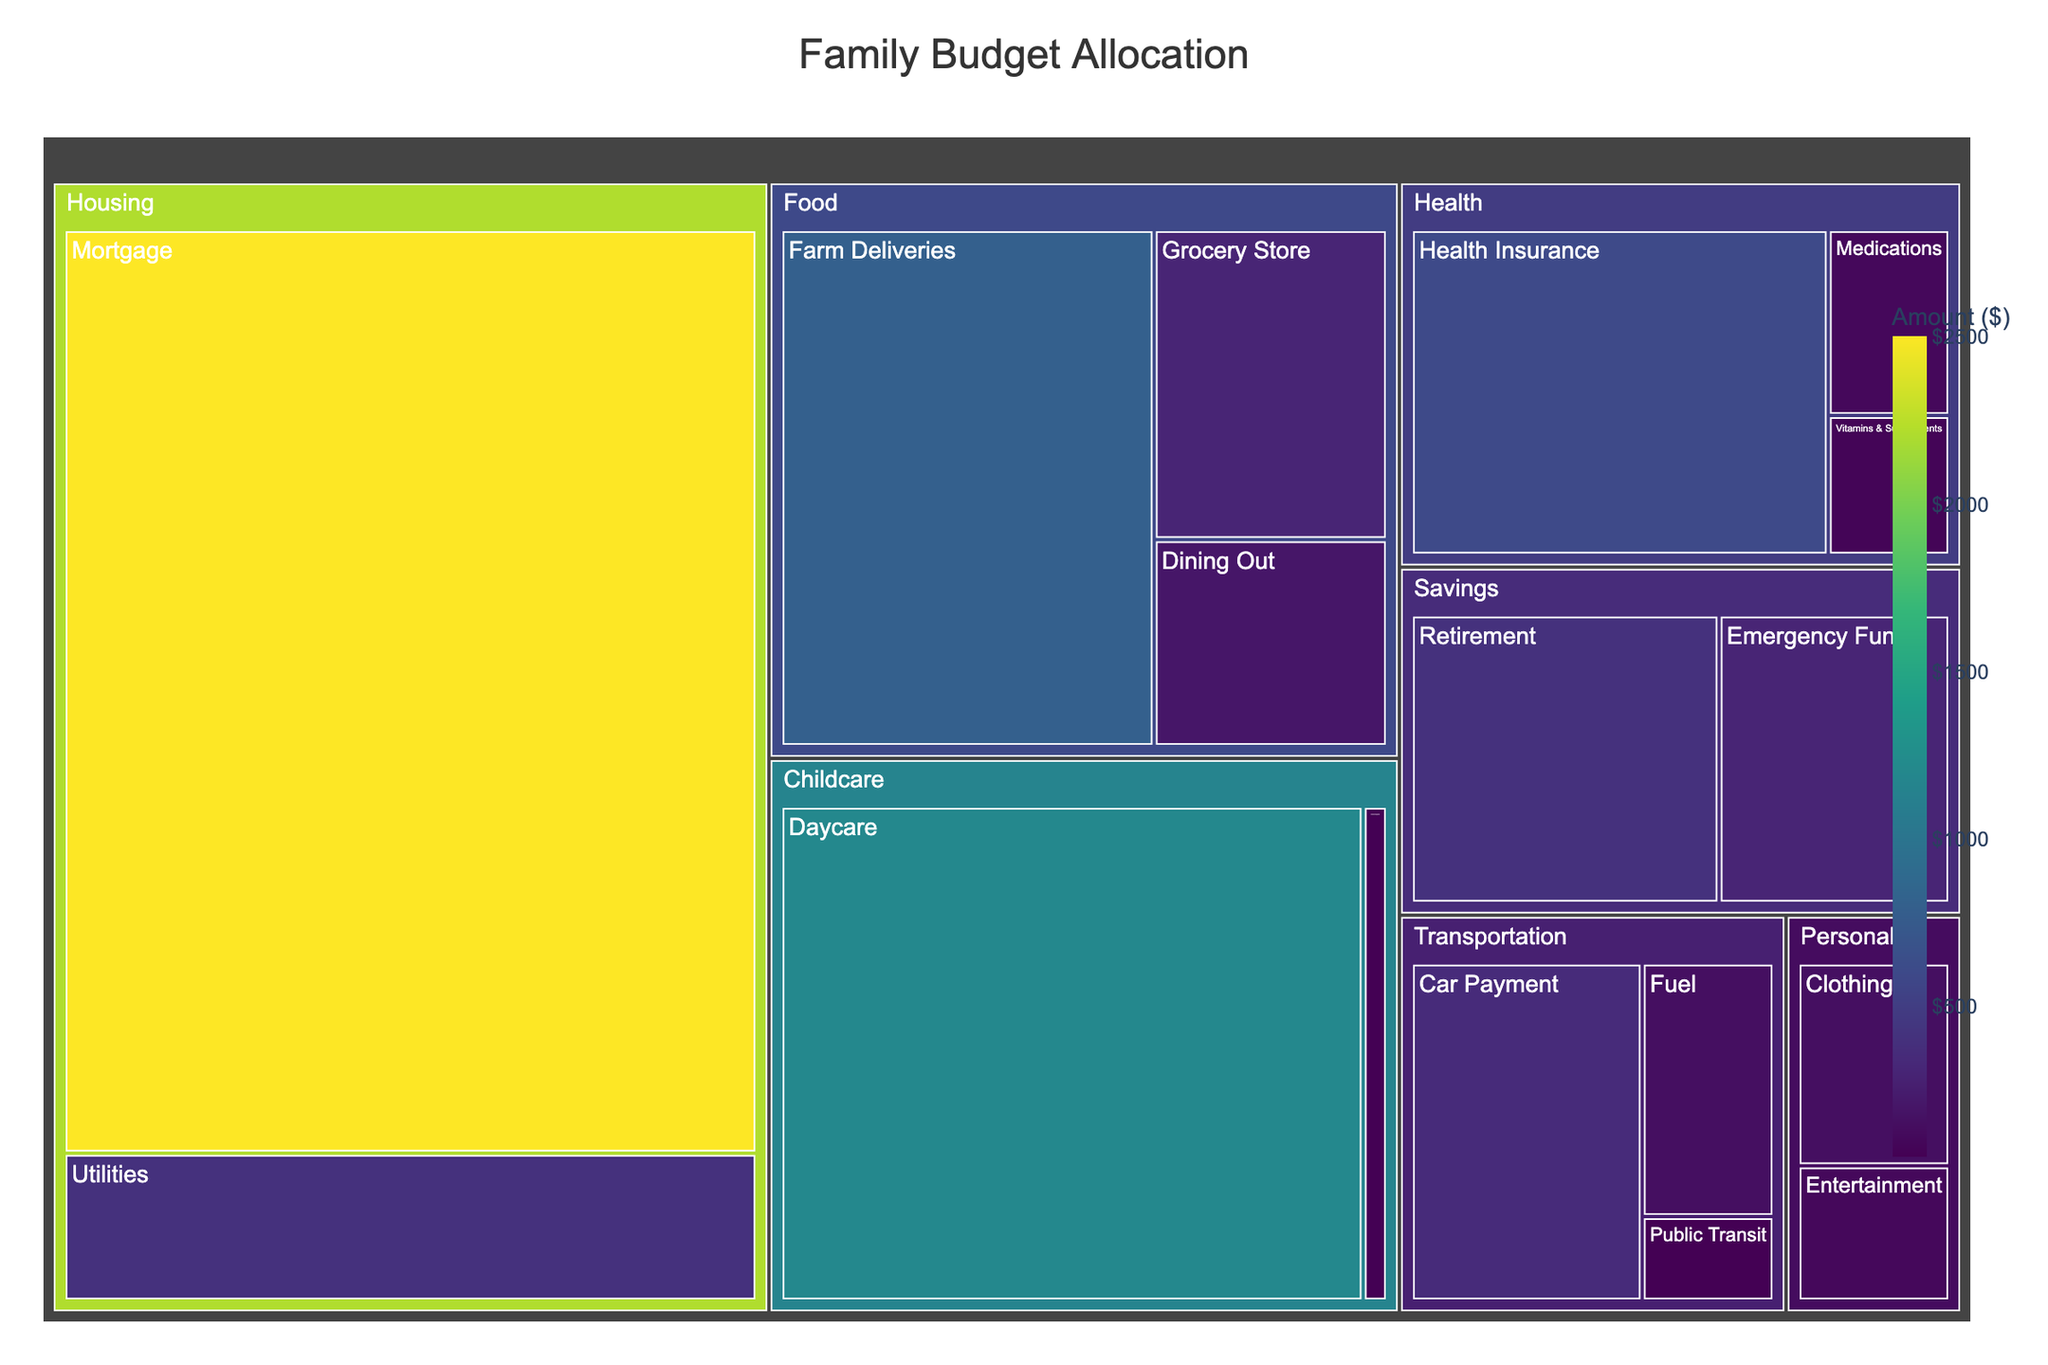How much is allocated to Farm Deliveries? Look at the Food category on the tree map and check the value labeled Farm Deliveries.
Answer: $800 What is the total amount spent on food-related expenses? Sum all the values within the Food category: Farm Deliveries ($800), Grocery Store ($300), and Dining Out ($200). The total is 800 + 300 + 200 = 1300.
Answer: $1300 Which subcategory within Health receives the largest budget allocation? Comparing Health Insurance ($600), Medications ($100), and Vitamins & Supplements ($75), the largest value is Health Insurance.
Answer: Health Insurance How does the spending on Daycare compare to that on Farm Deliveries? Identify the amounts for Daycare ($1200) and Farm Deliveries ($800). Since $1200 > $800, Daycare has a larger allocation.
Answer: Daycare has a larger allocation What is the difference in budget allocation between Housing and Health categories? Sum Housing category's values (Mortgage: $2500, Utilities: $400, total = 2500 + 400 = $2900) and Health category's values (Health Insurance: $600, Medications: $100, Vitamins & Supplements: $75, total = 600 + 100 + 75 = $775). The difference is 2900 - 775 = 2125.
Answer: $2125 What percentage of the total budget is allocated to the Food category? Calculate the total expenses by summing all values (2500 + 400 + 800 + 300 + 200 + 350 + 150 + 50 + 600 + 100 + 75 + 1200 + 50 + 150 + 100 + 300 + 400 = 7725). The Food category’s total is $1300. The percentage is (1300 / 7725) * 100 ≈ 16.82%.
Answer: ≈ 16.82% What's the smallest subcategory budget allocation in the entire family budget? Identify the smallest value across all categories: Housing (2500, 400), Food (800, 300, 200), Transportation (350, 150, 50), Health (600, 100, 75), Childcare (1200, 50), Personal (150, 100), Savings (300, 400). The smallest value is $50 (Public Transit and School Supplies).
Answer: $50 How much more is spent on Childcare compared to Personal expenses? Sum Childcare values (Daycare: $1200, School Supplies: $50, total = 1200 + 50 = $1250). Sum Personal values (Clothing: $150, Entertainment: $100, total = 150 + 100 = $250). The difference is 1250 - 250 = 1000.
Answer: $1000 What is the total allocation for Savings? Sum the values within the Savings category: Emergency Fund ($300) and Retirement ($400). The total is 300 + 400 = 700.
Answer: $700 Among the subcategories, which expense is the highest and what is that amount? Identify the highest value among all the subcategories. The largest single value is Mortgage in the Housing category ($2500).
Answer: Mortgage, $2500 